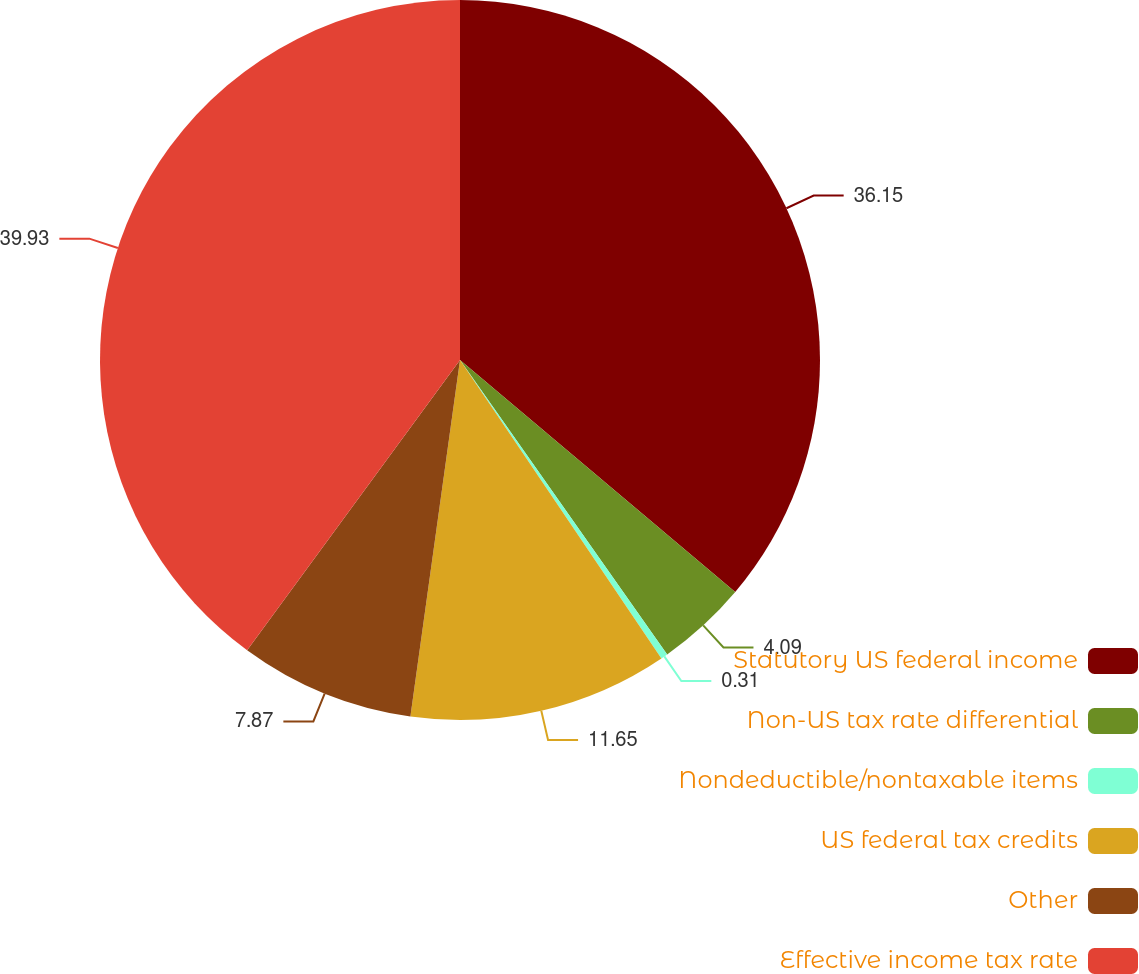<chart> <loc_0><loc_0><loc_500><loc_500><pie_chart><fcel>Statutory US federal income<fcel>Non-US tax rate differential<fcel>Nondeductible/nontaxable items<fcel>US federal tax credits<fcel>Other<fcel>Effective income tax rate<nl><fcel>36.15%<fcel>4.09%<fcel>0.31%<fcel>11.65%<fcel>7.87%<fcel>39.93%<nl></chart> 